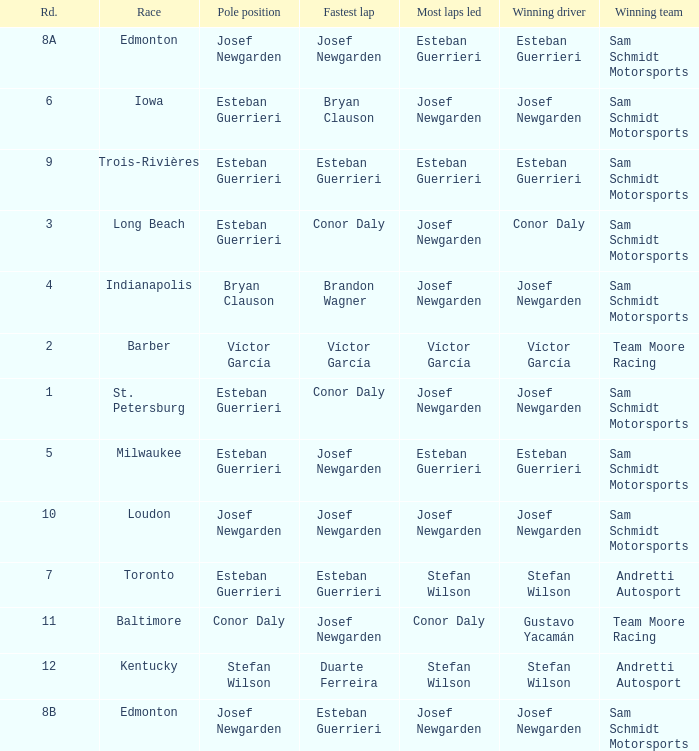Who had the fastest lap(s) when stefan wilson had the pole? Duarte Ferreira. 